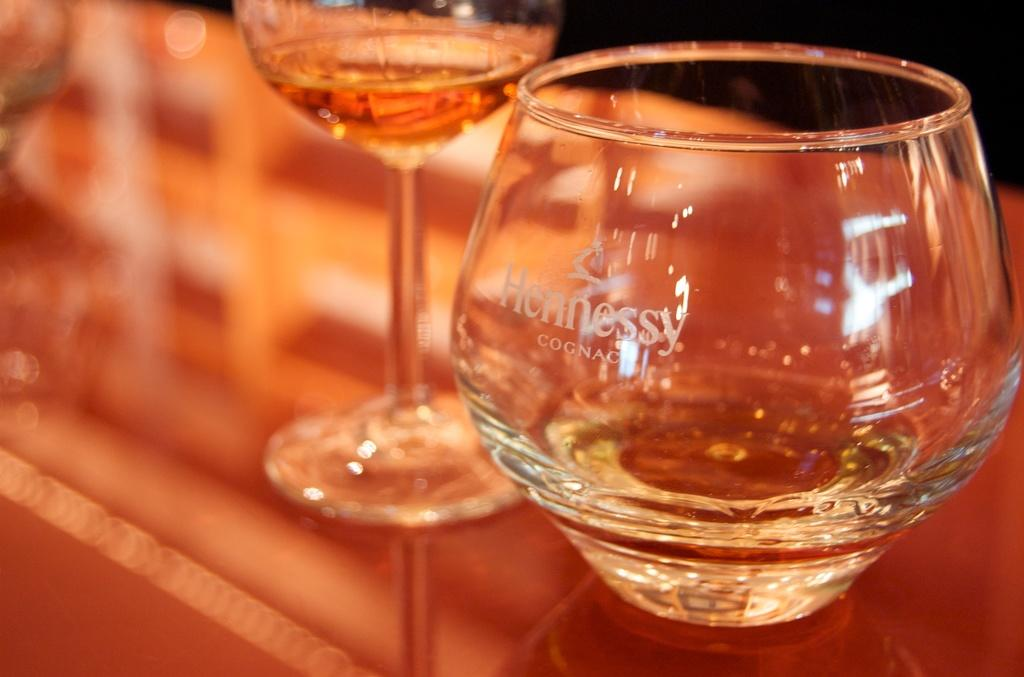What can be seen in the image related to beverages? There are two glasses of drinks in the image. What is written or printed on the glasses? There is text on the glasses. Can you describe the background of the image? The background of the image is blurry. What type of stamp can be seen on the glasses in the image? There is no stamp present on the glasses in the image. Can you tell me how many experts are visible in the image? There are no experts visible in the image. 